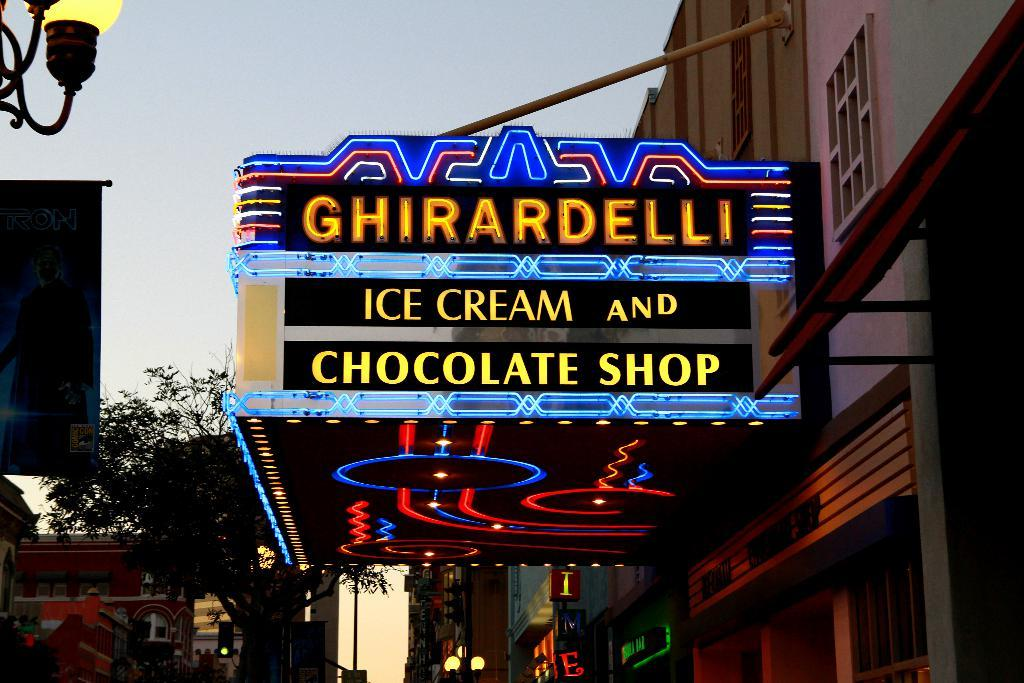What is written or displayed on the board in the image? There is a board with text in the image. What type of structures can be seen in the image? There are buildings in the image. What are the tall, vertical objects in the image? There are light poles in the image. What is hanging or displayed in the image? There is a banner in the image. What type of vegetation is present in the image? There are trees in the image. What color is the sky in the image? The sky is pale blue in the image. How many women are sitting on the wing of the airplane in the image? There is no airplane or wing present in the image, and therefore no women can be found sitting on it. 